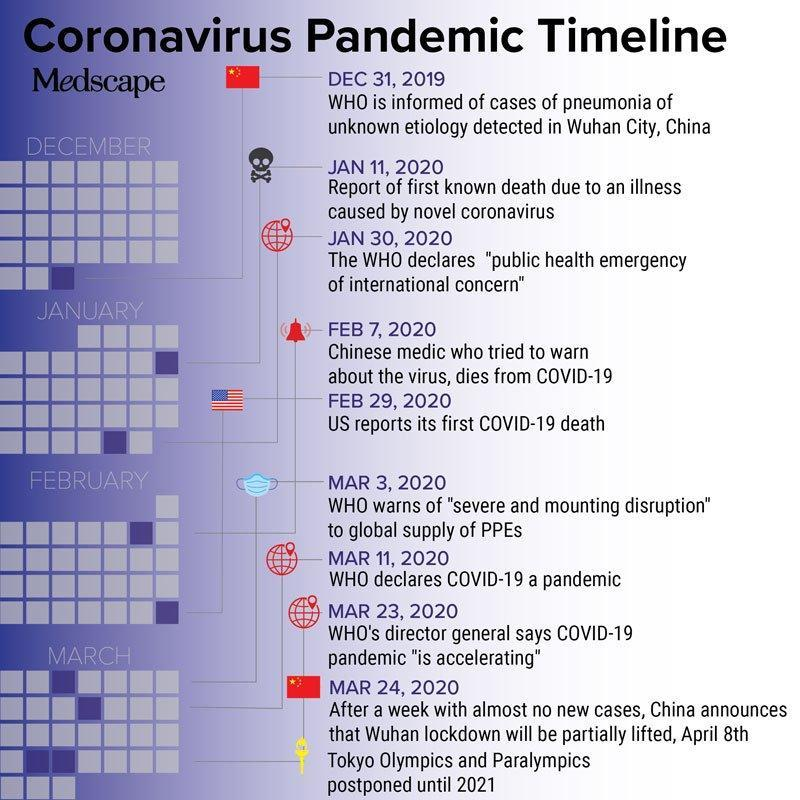When did the US reported its first Covid-19 death?
Answer the question with a short phrase. FEB 29, 2020 When did WHO declared COVID-19 as a pandemic? MAR 11, 2020 